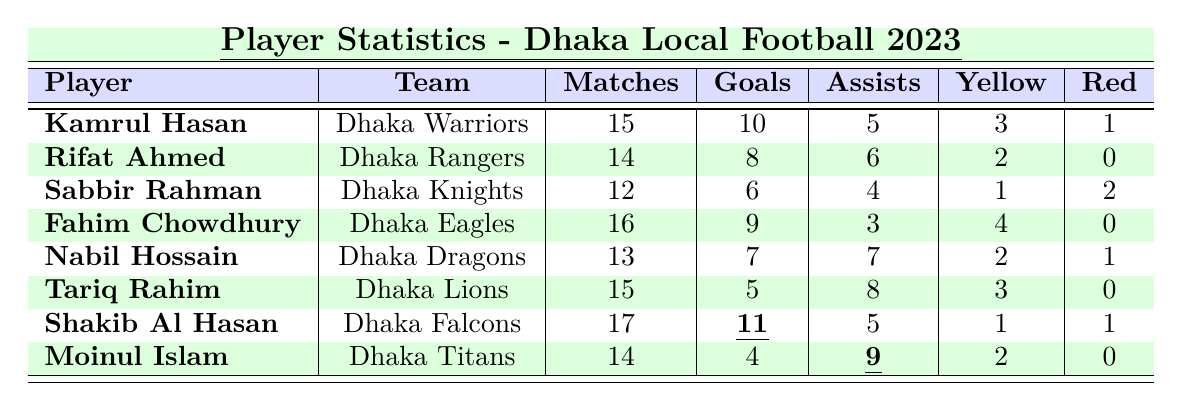What is the total number of goals scored by Kamrul Hasan? According to the table, Kamrul Hasan has scored 10 goals.
Answer: 10 How many matches did Rifat Ahmed play? The table indicates that Rifat Ahmed played a total of 14 matches.
Answer: 14 Who has the highest number of assists? By comparing the assists column, Moinul Islam has the highest number with 9 assists.
Answer: Moinul Islam How many red cards has Fahim Chowdhury received? The table shows that Fahim Chowdhury has received 0 red cards.
Answer: 0 What is the combined total of yellow and red cards for Nabil Hossain? Nabil Hossain has 2 yellow cards and 1 red card, totaling 2 + 1 = 3.
Answer: 3 Which player has the most goals and how many did they score? Shakib Al Hasan has the most goals with a total of 11.
Answer: Shakib Al Hasan, 11 If we look at the player with the least number of goals, who is it and how many goals did they score? Sabbir Rahman has the least number of goals among the listed players, scoring 6 goals.
Answer: Sabbir Rahman, 6 What is the average number of matches played by all players? The total matches played by all players is 15 + 14 + 12 + 16 + 13 + 15 + 17 + 14 = 121. There are 8 players, so the average is 121 / 8 = 15.125.
Answer: 15.125 True or False: Tariq Rahim has scored more goals than Nabil Hossain. Tariq Rahim scored 5 goals while Nabil Hossain scored 7 goals, making the statement false.
Answer: False What is the difference in the number of goals between Shakib Al Hasan and Kamrul Hasan? Shakib Al Hasan scored 11 goals, and Kamrul Hasan scored 10 goals. The difference is 11 - 10 = 1.
Answer: 1 